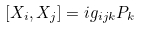<formula> <loc_0><loc_0><loc_500><loc_500>\left [ X _ { i } , X _ { j } \right ] = i g _ { i j k } P _ { k }</formula> 